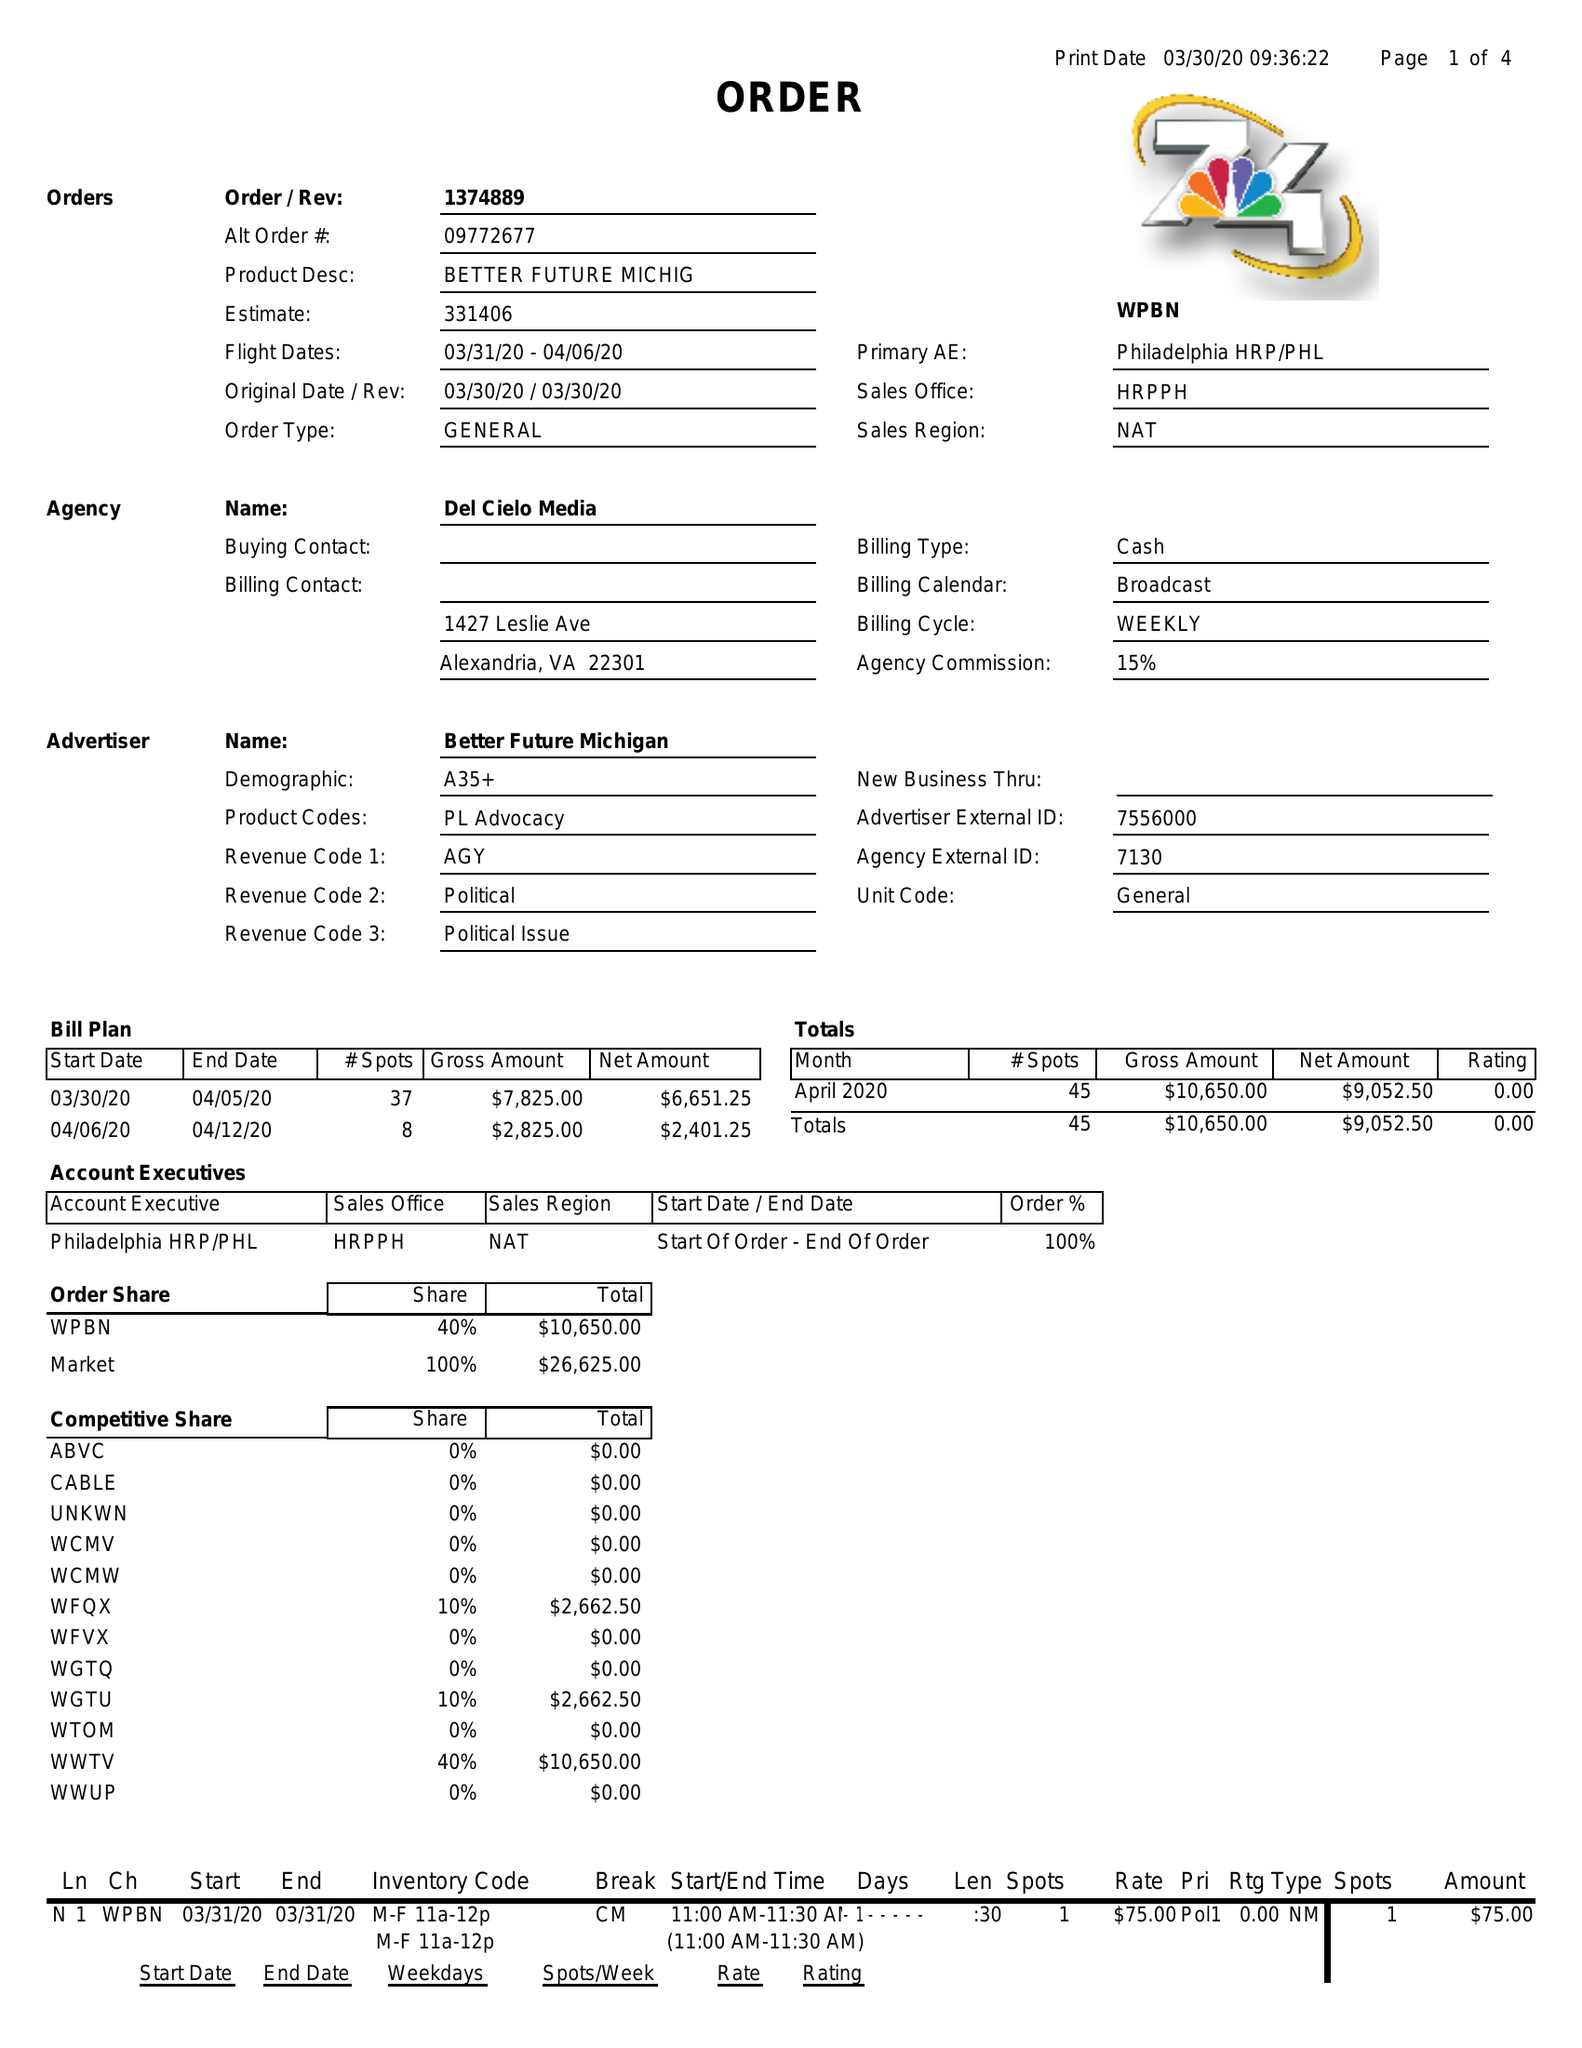What is the value for the advertiser?
Answer the question using a single word or phrase. BETTER FUTURE MICHIGAN 